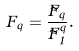<formula> <loc_0><loc_0><loc_500><loc_500>F _ { q } = \frac { \tilde { F } _ { q } } { \tilde { F } _ { 1 } ^ { q } } .</formula> 